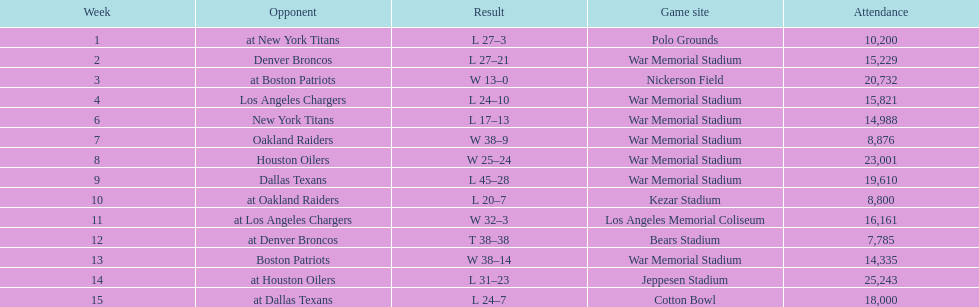How many games had an attendance of 10,000 at most? 11. 